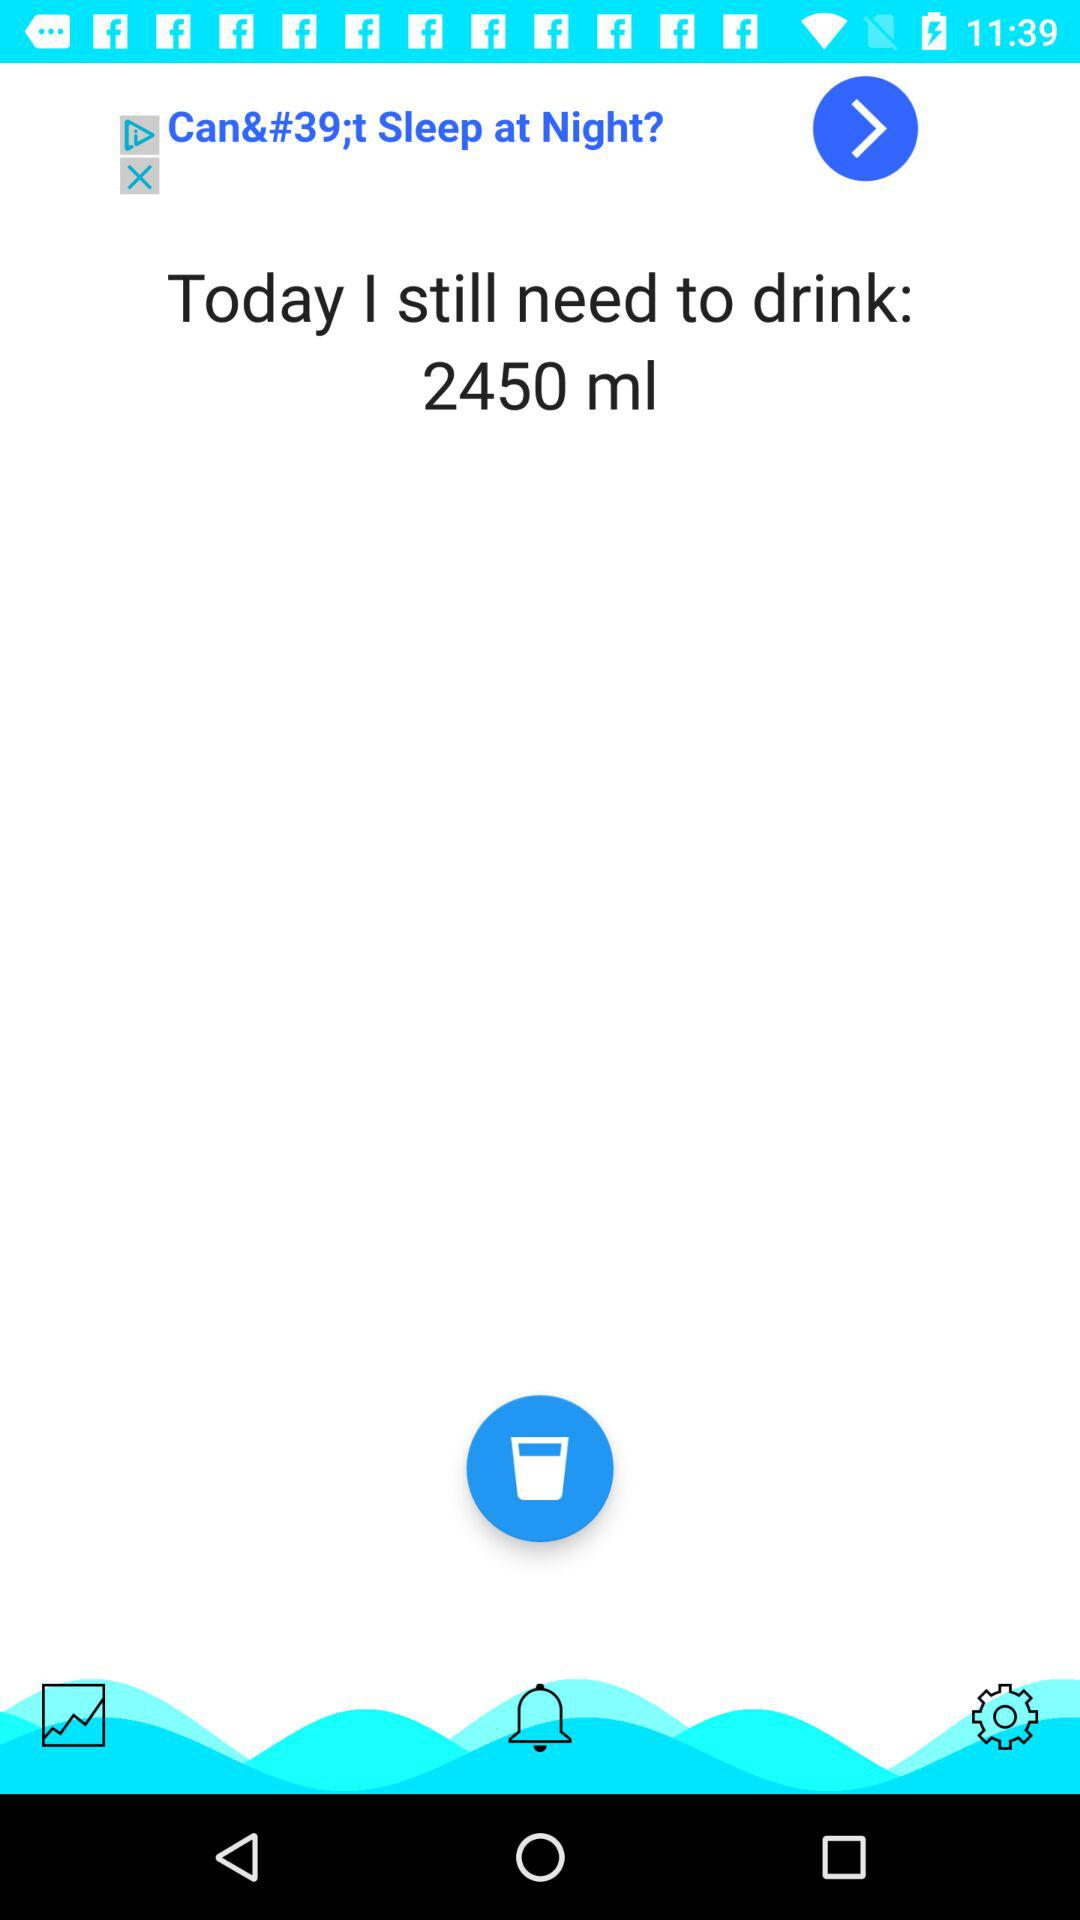How much more water do I need to drink?
Answer the question using a single word or phrase. 2450 ml 